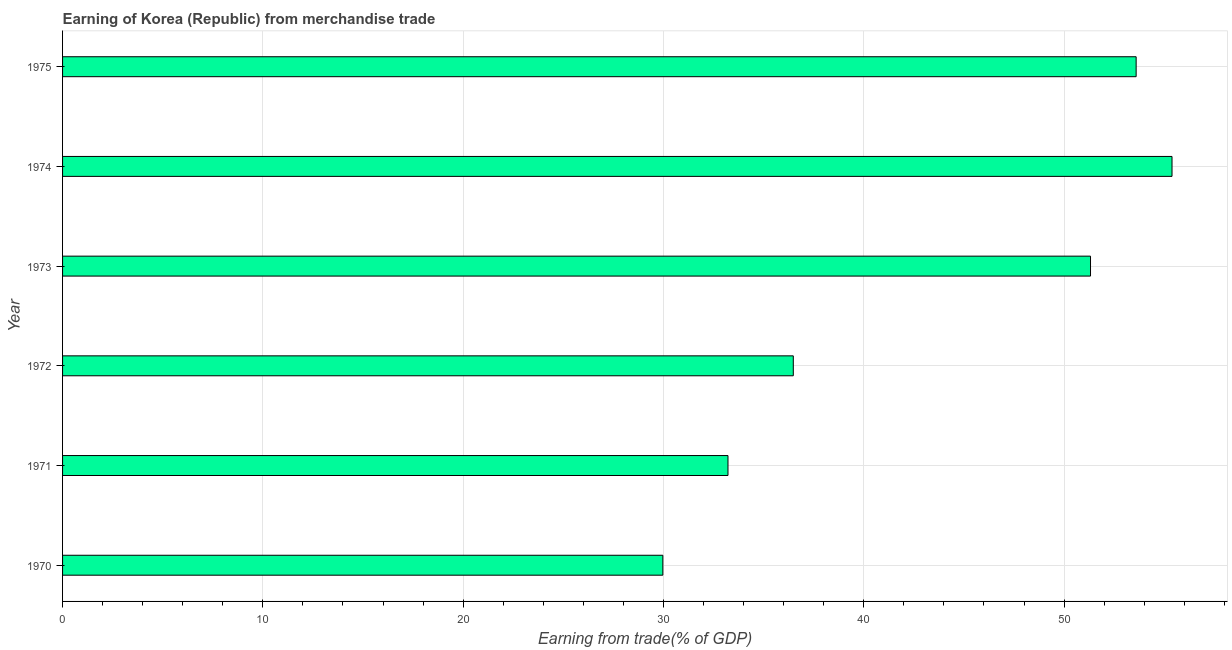Does the graph contain any zero values?
Give a very brief answer. No. What is the title of the graph?
Give a very brief answer. Earning of Korea (Republic) from merchandise trade. What is the label or title of the X-axis?
Offer a terse response. Earning from trade(% of GDP). What is the label or title of the Y-axis?
Make the answer very short. Year. What is the earning from merchandise trade in 1974?
Make the answer very short. 55.39. Across all years, what is the maximum earning from merchandise trade?
Give a very brief answer. 55.39. Across all years, what is the minimum earning from merchandise trade?
Your response must be concise. 29.97. In which year was the earning from merchandise trade maximum?
Provide a succinct answer. 1974. In which year was the earning from merchandise trade minimum?
Your answer should be very brief. 1970. What is the sum of the earning from merchandise trade?
Offer a very short reply. 259.98. What is the difference between the earning from merchandise trade in 1972 and 1975?
Offer a terse response. -17.12. What is the average earning from merchandise trade per year?
Give a very brief answer. 43.33. What is the median earning from merchandise trade?
Keep it short and to the point. 43.9. In how many years, is the earning from merchandise trade greater than 40 %?
Your response must be concise. 3. Do a majority of the years between 1974 and 1971 (inclusive) have earning from merchandise trade greater than 26 %?
Make the answer very short. Yes. Is the earning from merchandise trade in 1971 less than that in 1975?
Keep it short and to the point. Yes. Is the difference between the earning from merchandise trade in 1973 and 1974 greater than the difference between any two years?
Make the answer very short. No. What is the difference between the highest and the second highest earning from merchandise trade?
Your answer should be very brief. 1.79. What is the difference between the highest and the lowest earning from merchandise trade?
Ensure brevity in your answer.  25.42. How many bars are there?
Offer a terse response. 6. Are the values on the major ticks of X-axis written in scientific E-notation?
Your answer should be compact. No. What is the Earning from trade(% of GDP) in 1970?
Your answer should be very brief. 29.97. What is the Earning from trade(% of GDP) in 1971?
Make the answer very short. 33.22. What is the Earning from trade(% of GDP) of 1972?
Your answer should be very brief. 36.48. What is the Earning from trade(% of GDP) in 1973?
Provide a short and direct response. 51.32. What is the Earning from trade(% of GDP) of 1974?
Keep it short and to the point. 55.39. What is the Earning from trade(% of GDP) in 1975?
Give a very brief answer. 53.6. What is the difference between the Earning from trade(% of GDP) in 1970 and 1971?
Offer a very short reply. -3.25. What is the difference between the Earning from trade(% of GDP) in 1970 and 1972?
Ensure brevity in your answer.  -6.51. What is the difference between the Earning from trade(% of GDP) in 1970 and 1973?
Ensure brevity in your answer.  -21.35. What is the difference between the Earning from trade(% of GDP) in 1970 and 1974?
Your answer should be very brief. -25.42. What is the difference between the Earning from trade(% of GDP) in 1970 and 1975?
Your answer should be compact. -23.63. What is the difference between the Earning from trade(% of GDP) in 1971 and 1972?
Give a very brief answer. -3.26. What is the difference between the Earning from trade(% of GDP) in 1971 and 1973?
Offer a terse response. -18.1. What is the difference between the Earning from trade(% of GDP) in 1971 and 1974?
Offer a very short reply. -22.17. What is the difference between the Earning from trade(% of GDP) in 1971 and 1975?
Provide a short and direct response. -20.38. What is the difference between the Earning from trade(% of GDP) in 1972 and 1973?
Give a very brief answer. -14.84. What is the difference between the Earning from trade(% of GDP) in 1972 and 1974?
Offer a very short reply. -18.91. What is the difference between the Earning from trade(% of GDP) in 1972 and 1975?
Make the answer very short. -17.12. What is the difference between the Earning from trade(% of GDP) in 1973 and 1974?
Offer a terse response. -4.07. What is the difference between the Earning from trade(% of GDP) in 1973 and 1975?
Give a very brief answer. -2.28. What is the difference between the Earning from trade(% of GDP) in 1974 and 1975?
Provide a succinct answer. 1.79. What is the ratio of the Earning from trade(% of GDP) in 1970 to that in 1971?
Offer a very short reply. 0.9. What is the ratio of the Earning from trade(% of GDP) in 1970 to that in 1972?
Keep it short and to the point. 0.82. What is the ratio of the Earning from trade(% of GDP) in 1970 to that in 1973?
Your answer should be compact. 0.58. What is the ratio of the Earning from trade(% of GDP) in 1970 to that in 1974?
Provide a short and direct response. 0.54. What is the ratio of the Earning from trade(% of GDP) in 1970 to that in 1975?
Give a very brief answer. 0.56. What is the ratio of the Earning from trade(% of GDP) in 1971 to that in 1972?
Offer a terse response. 0.91. What is the ratio of the Earning from trade(% of GDP) in 1971 to that in 1973?
Provide a succinct answer. 0.65. What is the ratio of the Earning from trade(% of GDP) in 1971 to that in 1975?
Make the answer very short. 0.62. What is the ratio of the Earning from trade(% of GDP) in 1972 to that in 1973?
Give a very brief answer. 0.71. What is the ratio of the Earning from trade(% of GDP) in 1972 to that in 1974?
Your answer should be compact. 0.66. What is the ratio of the Earning from trade(% of GDP) in 1972 to that in 1975?
Ensure brevity in your answer.  0.68. What is the ratio of the Earning from trade(% of GDP) in 1973 to that in 1974?
Provide a succinct answer. 0.93. What is the ratio of the Earning from trade(% of GDP) in 1973 to that in 1975?
Provide a short and direct response. 0.96. What is the ratio of the Earning from trade(% of GDP) in 1974 to that in 1975?
Ensure brevity in your answer.  1.03. 